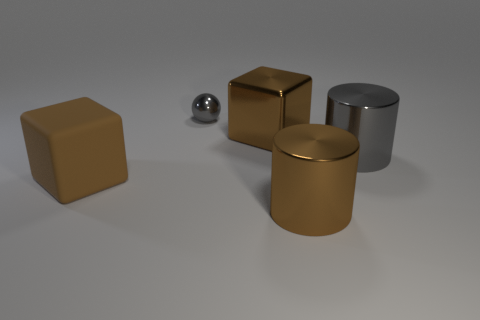What is the color of the large shiny thing that is the same shape as the big rubber object?
Offer a very short reply. Brown. What number of big metallic cylinders are the same color as the small object?
Your response must be concise. 1. There is a metal thing in front of the brown rubber object; does it have the same shape as the large gray shiny object?
Provide a succinct answer. Yes. What is the shape of the brown shiny object in front of the large block that is in front of the metal block that is to the right of the small gray shiny ball?
Offer a very short reply. Cylinder. How big is the gray metallic cylinder?
Provide a short and direct response. Large. There is a big cube that is made of the same material as the small ball; what is its color?
Make the answer very short. Brown. How many brown cubes have the same material as the small ball?
Your answer should be compact. 1. There is a matte cube; is its color the same as the large thing that is in front of the large brown matte thing?
Provide a short and direct response. Yes. There is a cube that is behind the gray cylinder in front of the metallic sphere; what is its color?
Provide a succinct answer. Brown. What is the color of the rubber object that is the same size as the brown metallic block?
Keep it short and to the point. Brown. 